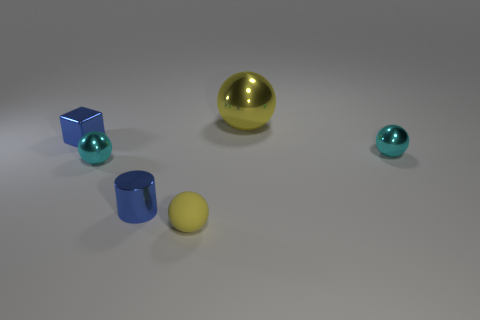Are there an equal number of big yellow objects that are left of the tiny blue shiny cylinder and tiny blue shiny blocks that are to the right of the block? yes 